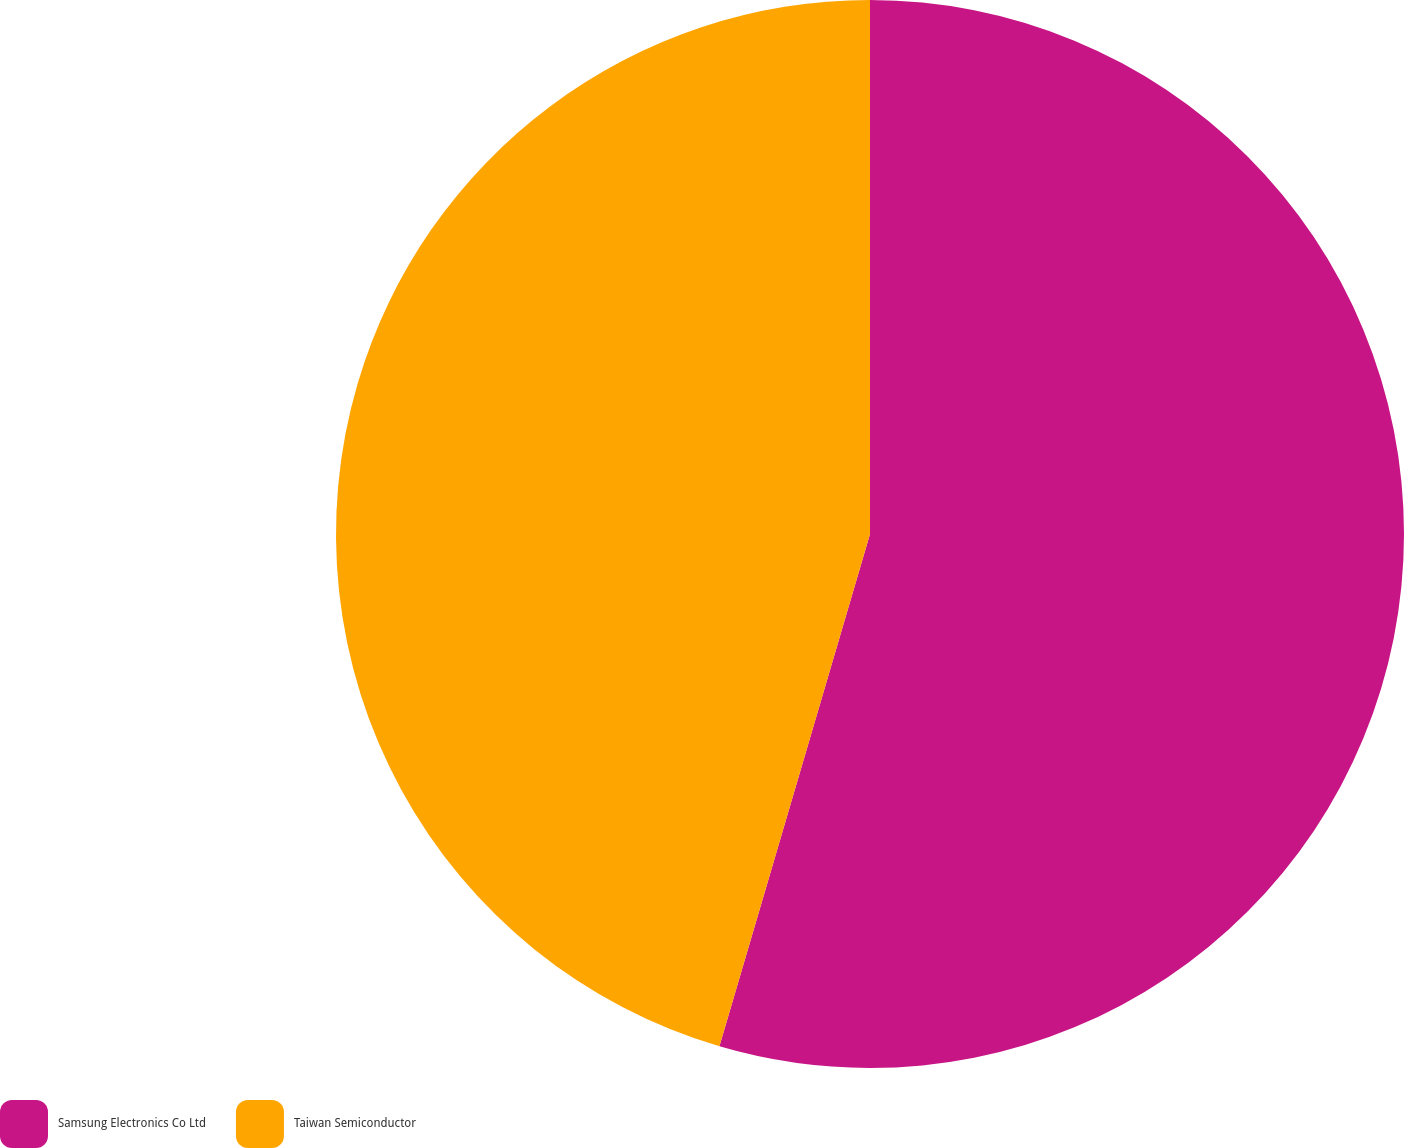Convert chart to OTSL. <chart><loc_0><loc_0><loc_500><loc_500><pie_chart><fcel>Samsung Electronics Co Ltd<fcel>Taiwan Semiconductor<nl><fcel>54.55%<fcel>45.45%<nl></chart> 